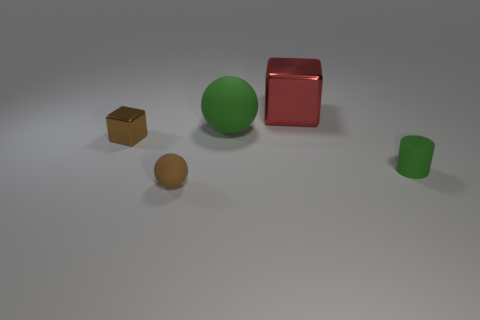There is a sphere behind the tiny brown ball; what is its size?
Provide a short and direct response. Large. Are there any large rubber cylinders that have the same color as the small metal block?
Your response must be concise. No. Do the small matte ball and the big shiny thing have the same color?
Offer a terse response. No. There is a matte object that is the same color as the big matte ball; what shape is it?
Your answer should be compact. Cylinder. How many spheres are in front of the metal object in front of the big rubber object?
Make the answer very short. 1. How many small green cylinders are made of the same material as the brown ball?
Your answer should be very brief. 1. Are there any red shiny cubes in front of the small cylinder?
Your response must be concise. No. There is a block that is the same size as the green matte cylinder; what color is it?
Your response must be concise. Brown. What number of objects are either small brown objects that are in front of the small metallic object or tiny red matte things?
Make the answer very short. 1. There is a matte object that is both on the left side of the small cylinder and right of the tiny matte ball; how big is it?
Your response must be concise. Large. 